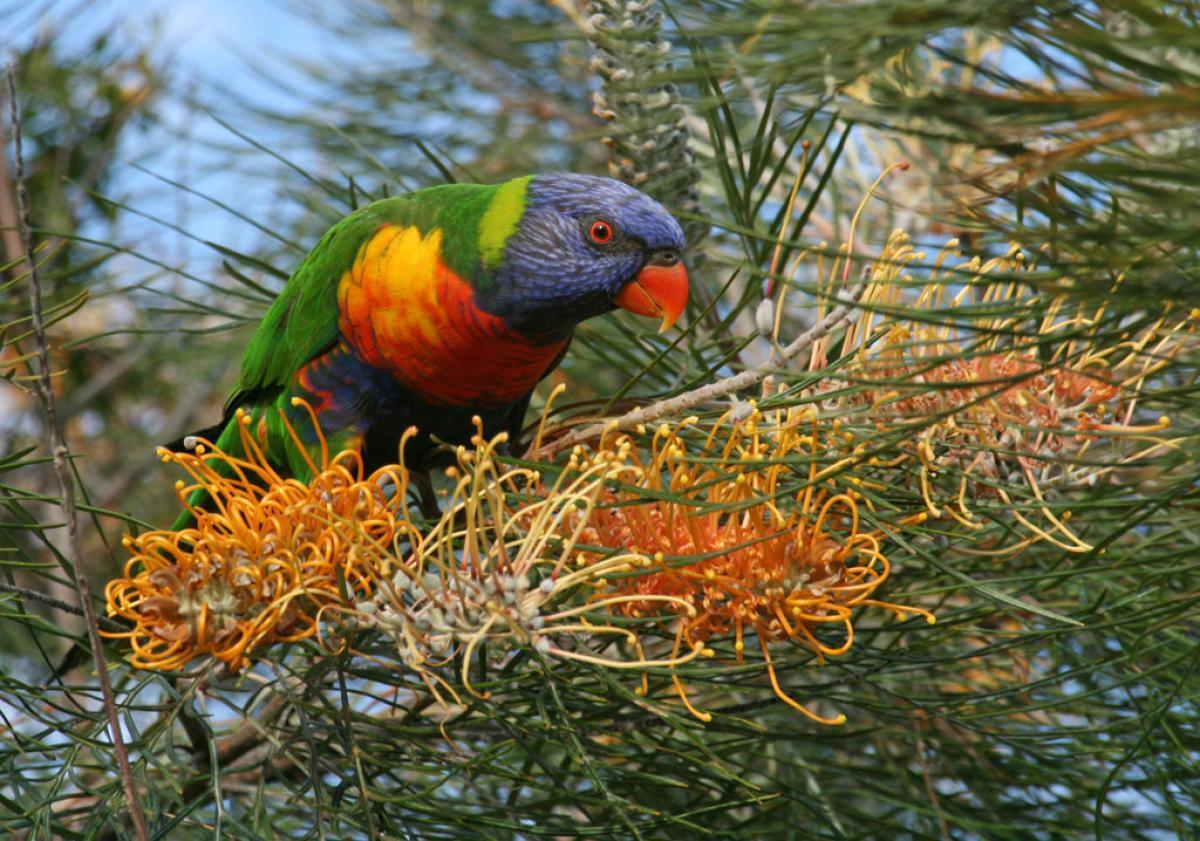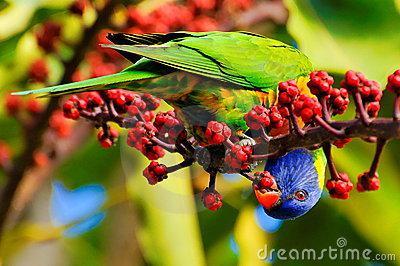The first image is the image on the left, the second image is the image on the right. For the images shown, is this caption "An image contains a single colorful bird perched near hot pink flowers with tendril-like petals." true? Answer yes or no. No. The first image is the image on the left, the second image is the image on the right. For the images displayed, is the sentence "In one of the images a colorful bird is sitting on a branch next to some bright pink flowers." factually correct? Answer yes or no. No. 